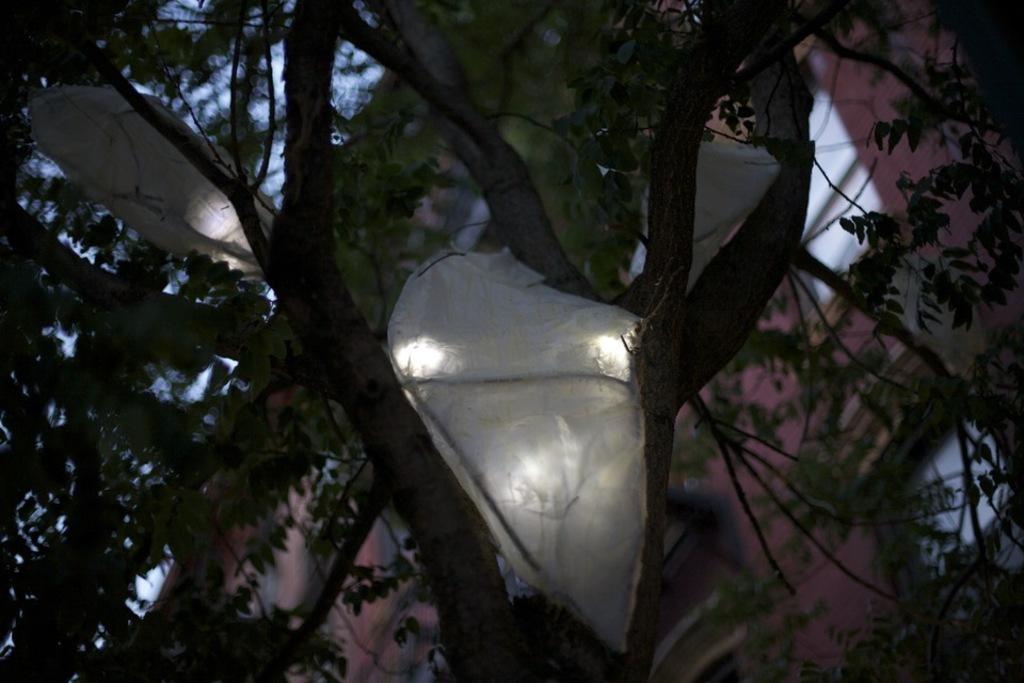Describe this image in one or two sentences. In this image in the foreground there is a tree, and on the tree there are white objects and some light is coming out from that objects. And there is a blurry background but we could see building and sky. 